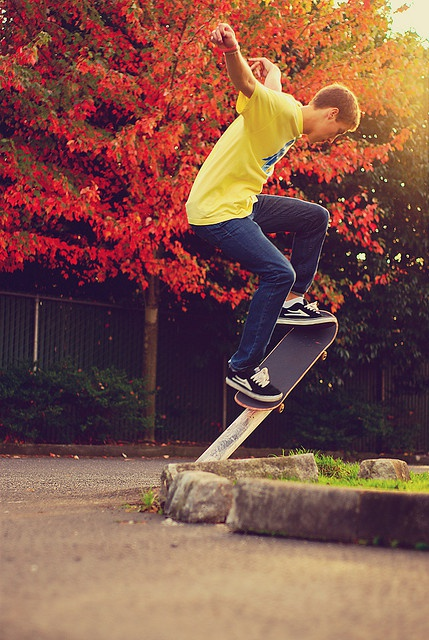Describe the objects in this image and their specific colors. I can see people in maroon, black, navy, gold, and khaki tones and skateboard in maroon, purple, black, and navy tones in this image. 